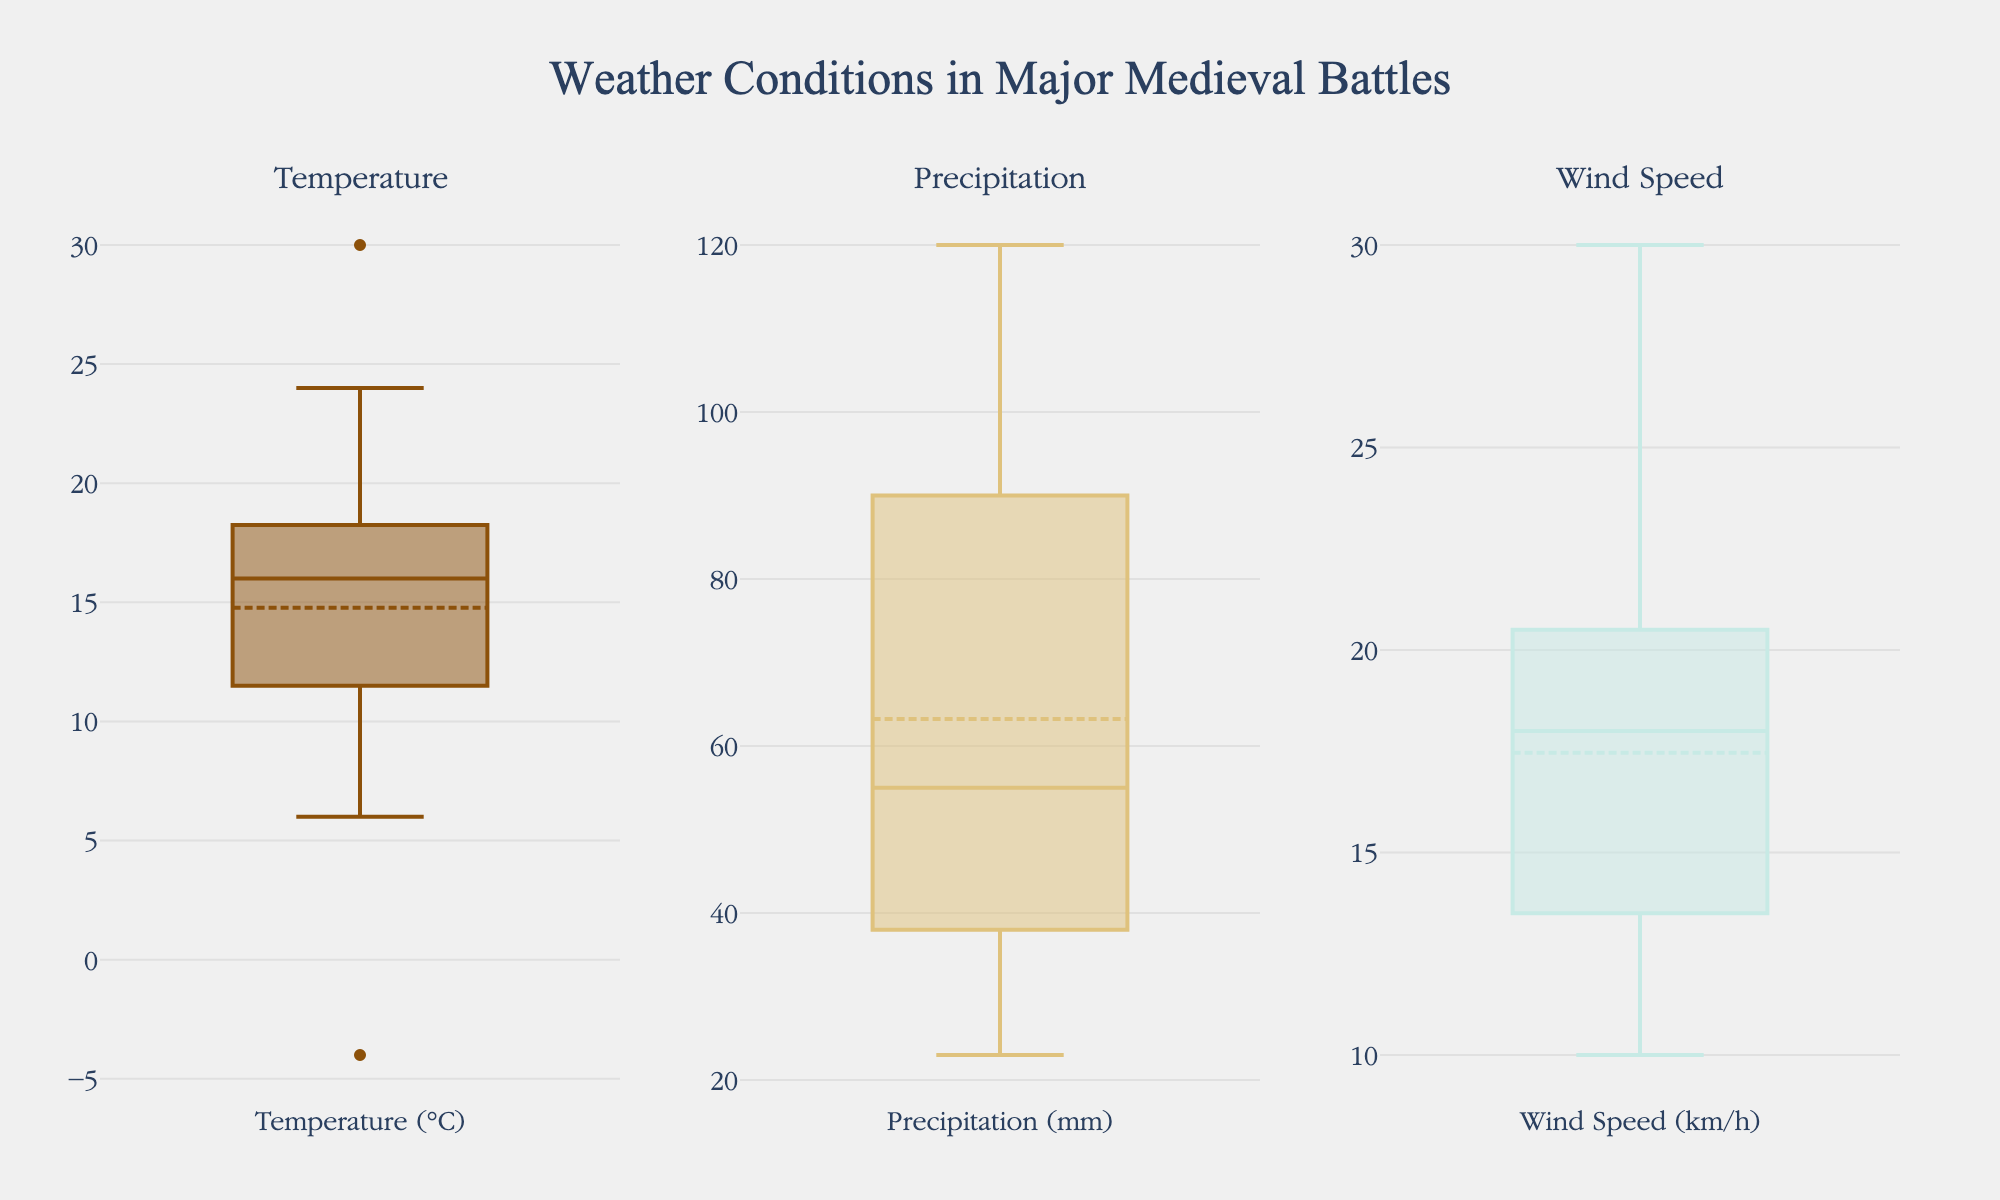which box plot shows the distribution of temperature during battles? The subplots are divided into three parts: Temperature, Precipitation, and Wind Speed. The first subplot, on the left, is titled "Temperature".
Answer: The first subplot (left) what is the median temperature during these battles? From the first subplot titled "Temperature", the median value can be found at the central horizontal line within the box. It appears to be around 16°C.
Answer: 16°C which battle occurred during the highest recorded temperature? Hover over the highest point in the “Temperature” subplot to see the tooltip, which shows the Battle of Stalingrad with a temperature of 30°C.
Answer: Battle of Stalingrad which battle had the most precipitation? In the second subplot titled "Precipitation", hover over the highest point, which shows the Battle of Sekigahara with 120 mm of precipitation.
Answer: Battle of Sekigahara how many battles had a temperature below 10°C? In the first subplot (Temperature), count the number of points below the 10°C mark. These points are two: from the Battle of Hastings and the Battle of the Bulge.
Answer: 2 which battle had the highest wind speed? Hover over the highest point in the third subplot titled "Wind Speed". The tooltip indicates the Battle of Gettysburg with a wind speed of 30 km/h.
Answer: Battle of Gettysburg which plot has a narrower interquartile range (IQR), temperature or wind speed? The IQR is the length of the box in each subplot. The Wind Speed subplot has a narrower box compared to the Temperature subplot, indicating that wind speed has a smaller interquartile range.
Answer: Wind Speed which two battles have the same amount of precipitation and what is the value? In the second subplot (Precipitation), hover over the points that look like they are at the same level. The Battle of Agincourt and the Battle of the Bulge both have 40 mm of precipitation.
Answer: Battle of Agincourt and Battle of the Bulge, 40 mm what is the approximate range of wind speeds recorded during these battles? In the Wind Speed subplot, the lowest point is around 10 km/h and the highest is around 30 km/h, indicating a range of approximately 20 km/h.
Answer: 10-30 km/h 